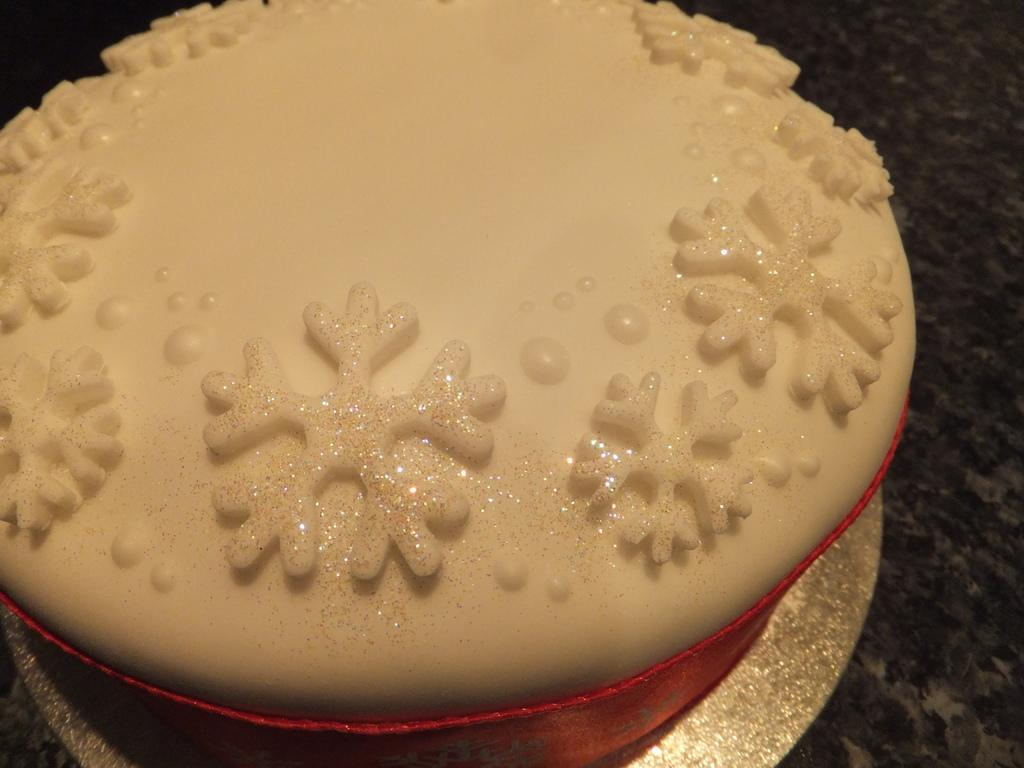What is the main subject of the image? There is a cake in the image. Where is the cake located? The cake is on a table. What can be observed on the surface of the cake? The cake has designs and dots on it. What color is the cloth around the cake? The cloth around the cake is red. Is there a veil covering the cake in the image? No, there is no veil present in the image. What type of cent is depicted on the cake? There is no cent or any other currency symbol on the cake; it has designs and dots. 